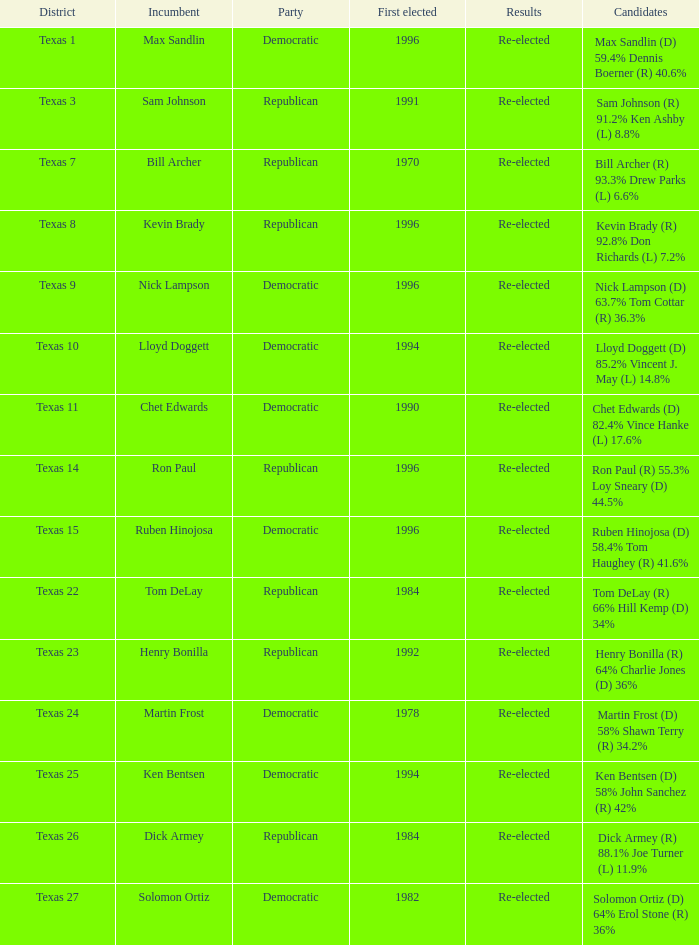What district is nick lampson from? Texas 9. 